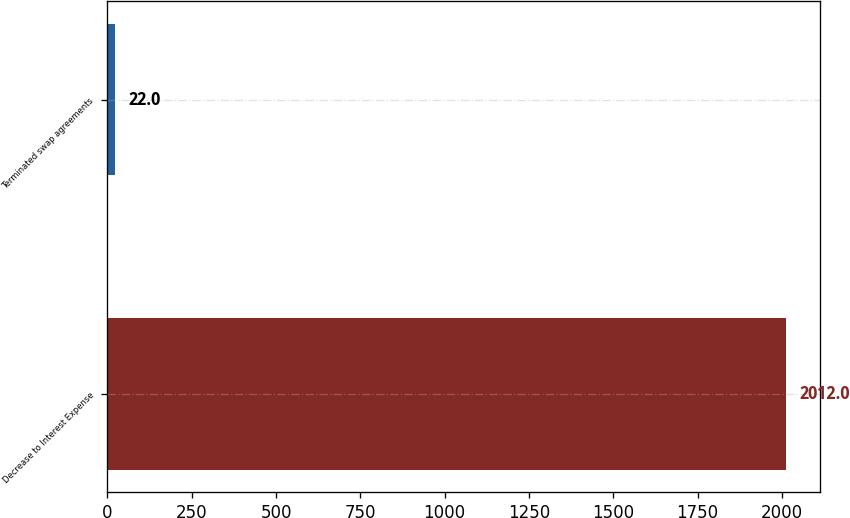Convert chart to OTSL. <chart><loc_0><loc_0><loc_500><loc_500><bar_chart><fcel>Decrease to Interest Expense<fcel>Terminated swap agreements<nl><fcel>2012<fcel>22<nl></chart> 